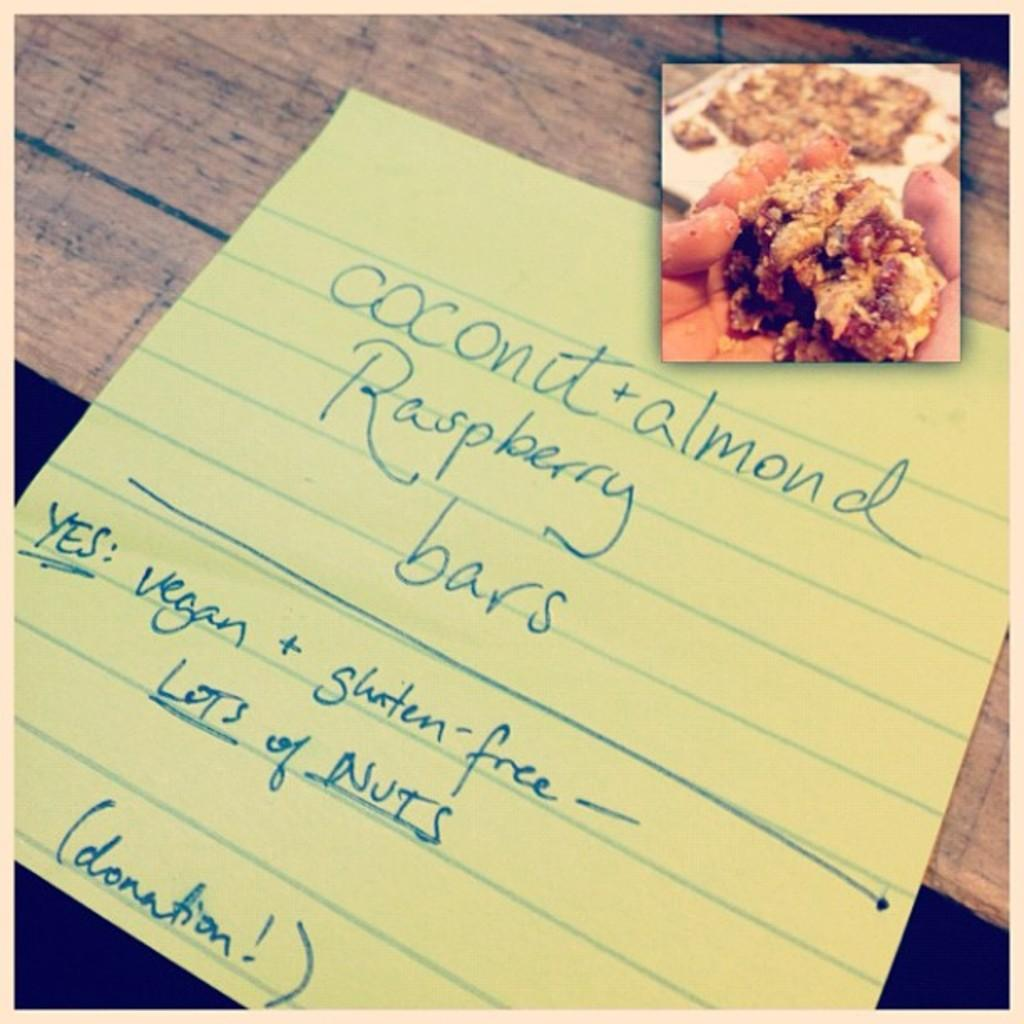<image>
Share a concise interpretation of the image provided. A note that describes features of coconut and almond raspberry bars 